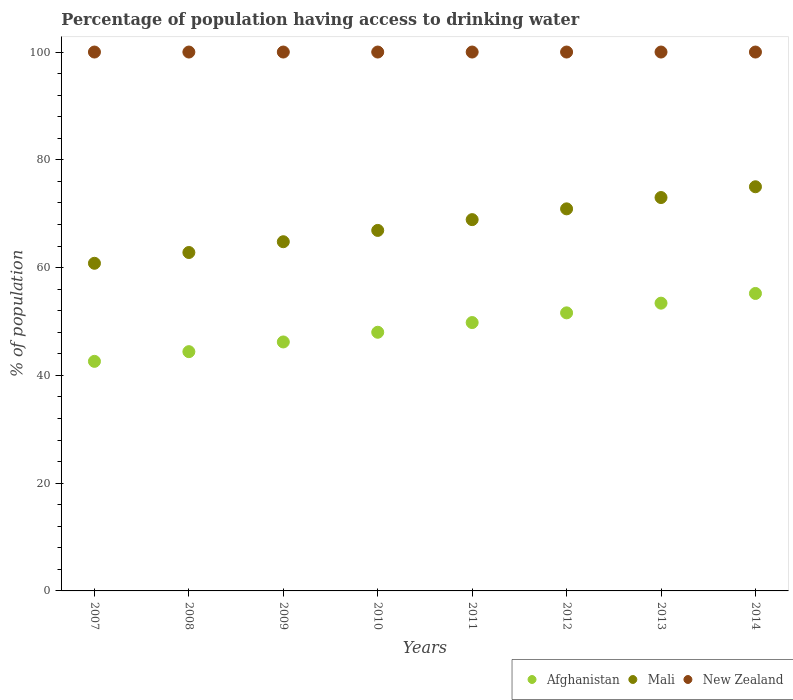What is the percentage of population having access to drinking water in New Zealand in 2009?
Make the answer very short. 100. Across all years, what is the maximum percentage of population having access to drinking water in Mali?
Make the answer very short. 75. Across all years, what is the minimum percentage of population having access to drinking water in New Zealand?
Ensure brevity in your answer.  100. In which year was the percentage of population having access to drinking water in Mali maximum?
Ensure brevity in your answer.  2014. What is the total percentage of population having access to drinking water in Afghanistan in the graph?
Provide a short and direct response. 391.2. What is the difference between the percentage of population having access to drinking water in Afghanistan in 2010 and that in 2013?
Your answer should be compact. -5.4. What is the difference between the percentage of population having access to drinking water in New Zealand in 2009 and the percentage of population having access to drinking water in Mali in 2008?
Give a very brief answer. 37.2. What is the average percentage of population having access to drinking water in New Zealand per year?
Ensure brevity in your answer.  100. In the year 2009, what is the difference between the percentage of population having access to drinking water in Mali and percentage of population having access to drinking water in New Zealand?
Your answer should be compact. -35.2. In how many years, is the percentage of population having access to drinking water in Mali greater than 76 %?
Your answer should be compact. 0. What is the ratio of the percentage of population having access to drinking water in Afghanistan in 2011 to that in 2012?
Offer a terse response. 0.97. What is the difference between the highest and the lowest percentage of population having access to drinking water in Afghanistan?
Make the answer very short. 12.6. Is the sum of the percentage of population having access to drinking water in New Zealand in 2009 and 2014 greater than the maximum percentage of population having access to drinking water in Mali across all years?
Your response must be concise. Yes. Is it the case that in every year, the sum of the percentage of population having access to drinking water in Mali and percentage of population having access to drinking water in New Zealand  is greater than the percentage of population having access to drinking water in Afghanistan?
Keep it short and to the point. Yes. Is the percentage of population having access to drinking water in Afghanistan strictly less than the percentage of population having access to drinking water in New Zealand over the years?
Ensure brevity in your answer.  Yes. How many dotlines are there?
Make the answer very short. 3. How many years are there in the graph?
Your answer should be very brief. 8. What is the difference between two consecutive major ticks on the Y-axis?
Provide a succinct answer. 20. Does the graph contain grids?
Keep it short and to the point. No. How are the legend labels stacked?
Keep it short and to the point. Horizontal. What is the title of the graph?
Your answer should be compact. Percentage of population having access to drinking water. What is the label or title of the X-axis?
Give a very brief answer. Years. What is the label or title of the Y-axis?
Provide a short and direct response. % of population. What is the % of population of Afghanistan in 2007?
Make the answer very short. 42.6. What is the % of population of Mali in 2007?
Keep it short and to the point. 60.8. What is the % of population in Afghanistan in 2008?
Provide a succinct answer. 44.4. What is the % of population in Mali in 2008?
Your answer should be compact. 62.8. What is the % of population in Afghanistan in 2009?
Offer a terse response. 46.2. What is the % of population of Mali in 2009?
Give a very brief answer. 64.8. What is the % of population in New Zealand in 2009?
Provide a short and direct response. 100. What is the % of population in Mali in 2010?
Your answer should be very brief. 66.9. What is the % of population of Afghanistan in 2011?
Give a very brief answer. 49.8. What is the % of population in Mali in 2011?
Ensure brevity in your answer.  68.9. What is the % of population of Afghanistan in 2012?
Offer a very short reply. 51.6. What is the % of population in Mali in 2012?
Your response must be concise. 70.9. What is the % of population in Afghanistan in 2013?
Make the answer very short. 53.4. What is the % of population in Mali in 2013?
Provide a succinct answer. 73. What is the % of population of Afghanistan in 2014?
Offer a terse response. 55.2. Across all years, what is the maximum % of population in Afghanistan?
Your response must be concise. 55.2. Across all years, what is the minimum % of population in Afghanistan?
Offer a very short reply. 42.6. Across all years, what is the minimum % of population in Mali?
Keep it short and to the point. 60.8. Across all years, what is the minimum % of population of New Zealand?
Ensure brevity in your answer.  100. What is the total % of population in Afghanistan in the graph?
Keep it short and to the point. 391.2. What is the total % of population in Mali in the graph?
Your response must be concise. 543.1. What is the total % of population of New Zealand in the graph?
Offer a very short reply. 800. What is the difference between the % of population in Afghanistan in 2007 and that in 2008?
Your answer should be compact. -1.8. What is the difference between the % of population of New Zealand in 2007 and that in 2008?
Your answer should be very brief. 0. What is the difference between the % of population in Afghanistan in 2007 and that in 2009?
Your response must be concise. -3.6. What is the difference between the % of population of Afghanistan in 2007 and that in 2010?
Provide a succinct answer. -5.4. What is the difference between the % of population in Mali in 2007 and that in 2011?
Your answer should be very brief. -8.1. What is the difference between the % of population in Afghanistan in 2007 and that in 2012?
Make the answer very short. -9. What is the difference between the % of population in Mali in 2007 and that in 2012?
Make the answer very short. -10.1. What is the difference between the % of population in New Zealand in 2007 and that in 2012?
Make the answer very short. 0. What is the difference between the % of population of Mali in 2007 and that in 2013?
Provide a succinct answer. -12.2. What is the difference between the % of population of Mali in 2007 and that in 2014?
Your answer should be very brief. -14.2. What is the difference between the % of population of Afghanistan in 2008 and that in 2009?
Your answer should be compact. -1.8. What is the difference between the % of population of Mali in 2008 and that in 2009?
Keep it short and to the point. -2. What is the difference between the % of population of Afghanistan in 2008 and that in 2011?
Make the answer very short. -5.4. What is the difference between the % of population in Mali in 2008 and that in 2011?
Offer a very short reply. -6.1. What is the difference between the % of population of Mali in 2008 and that in 2012?
Ensure brevity in your answer.  -8.1. What is the difference between the % of population of New Zealand in 2008 and that in 2012?
Provide a short and direct response. 0. What is the difference between the % of population in Mali in 2008 and that in 2014?
Make the answer very short. -12.2. What is the difference between the % of population in Mali in 2009 and that in 2010?
Give a very brief answer. -2.1. What is the difference between the % of population of Afghanistan in 2009 and that in 2011?
Provide a succinct answer. -3.6. What is the difference between the % of population in New Zealand in 2009 and that in 2012?
Make the answer very short. 0. What is the difference between the % of population in Afghanistan in 2009 and that in 2013?
Provide a succinct answer. -7.2. What is the difference between the % of population in Mali in 2009 and that in 2013?
Your response must be concise. -8.2. What is the difference between the % of population in Afghanistan in 2009 and that in 2014?
Ensure brevity in your answer.  -9. What is the difference between the % of population in New Zealand in 2009 and that in 2014?
Your answer should be compact. 0. What is the difference between the % of population in Afghanistan in 2010 and that in 2011?
Offer a terse response. -1.8. What is the difference between the % of population of Afghanistan in 2010 and that in 2012?
Keep it short and to the point. -3.6. What is the difference between the % of population in New Zealand in 2010 and that in 2012?
Offer a terse response. 0. What is the difference between the % of population of New Zealand in 2010 and that in 2013?
Your answer should be very brief. 0. What is the difference between the % of population of Mali in 2010 and that in 2014?
Provide a short and direct response. -8.1. What is the difference between the % of population of New Zealand in 2010 and that in 2014?
Make the answer very short. 0. What is the difference between the % of population in Afghanistan in 2011 and that in 2012?
Make the answer very short. -1.8. What is the difference between the % of population in New Zealand in 2011 and that in 2012?
Provide a short and direct response. 0. What is the difference between the % of population in Mali in 2011 and that in 2013?
Ensure brevity in your answer.  -4.1. What is the difference between the % of population in New Zealand in 2011 and that in 2013?
Provide a short and direct response. 0. What is the difference between the % of population of Afghanistan in 2011 and that in 2014?
Offer a very short reply. -5.4. What is the difference between the % of population in Mali in 2011 and that in 2014?
Make the answer very short. -6.1. What is the difference between the % of population of New Zealand in 2011 and that in 2014?
Provide a short and direct response. 0. What is the difference between the % of population of Afghanistan in 2013 and that in 2014?
Your response must be concise. -1.8. What is the difference between the % of population in Mali in 2013 and that in 2014?
Offer a terse response. -2. What is the difference between the % of population in New Zealand in 2013 and that in 2014?
Your answer should be compact. 0. What is the difference between the % of population in Afghanistan in 2007 and the % of population in Mali in 2008?
Offer a terse response. -20.2. What is the difference between the % of population in Afghanistan in 2007 and the % of population in New Zealand in 2008?
Your answer should be compact. -57.4. What is the difference between the % of population of Mali in 2007 and the % of population of New Zealand in 2008?
Your answer should be compact. -39.2. What is the difference between the % of population in Afghanistan in 2007 and the % of population in Mali in 2009?
Provide a succinct answer. -22.2. What is the difference between the % of population in Afghanistan in 2007 and the % of population in New Zealand in 2009?
Offer a terse response. -57.4. What is the difference between the % of population in Mali in 2007 and the % of population in New Zealand in 2009?
Your answer should be compact. -39.2. What is the difference between the % of population of Afghanistan in 2007 and the % of population of Mali in 2010?
Offer a terse response. -24.3. What is the difference between the % of population in Afghanistan in 2007 and the % of population in New Zealand in 2010?
Your answer should be compact. -57.4. What is the difference between the % of population of Mali in 2007 and the % of population of New Zealand in 2010?
Provide a succinct answer. -39.2. What is the difference between the % of population of Afghanistan in 2007 and the % of population of Mali in 2011?
Offer a terse response. -26.3. What is the difference between the % of population in Afghanistan in 2007 and the % of population in New Zealand in 2011?
Give a very brief answer. -57.4. What is the difference between the % of population in Mali in 2007 and the % of population in New Zealand in 2011?
Offer a very short reply. -39.2. What is the difference between the % of population of Afghanistan in 2007 and the % of population of Mali in 2012?
Your answer should be compact. -28.3. What is the difference between the % of population of Afghanistan in 2007 and the % of population of New Zealand in 2012?
Provide a short and direct response. -57.4. What is the difference between the % of population of Mali in 2007 and the % of population of New Zealand in 2012?
Give a very brief answer. -39.2. What is the difference between the % of population of Afghanistan in 2007 and the % of population of Mali in 2013?
Ensure brevity in your answer.  -30.4. What is the difference between the % of population in Afghanistan in 2007 and the % of population in New Zealand in 2013?
Keep it short and to the point. -57.4. What is the difference between the % of population in Mali in 2007 and the % of population in New Zealand in 2013?
Keep it short and to the point. -39.2. What is the difference between the % of population of Afghanistan in 2007 and the % of population of Mali in 2014?
Keep it short and to the point. -32.4. What is the difference between the % of population in Afghanistan in 2007 and the % of population in New Zealand in 2014?
Ensure brevity in your answer.  -57.4. What is the difference between the % of population of Mali in 2007 and the % of population of New Zealand in 2014?
Your answer should be compact. -39.2. What is the difference between the % of population of Afghanistan in 2008 and the % of population of Mali in 2009?
Provide a short and direct response. -20.4. What is the difference between the % of population of Afghanistan in 2008 and the % of population of New Zealand in 2009?
Offer a terse response. -55.6. What is the difference between the % of population of Mali in 2008 and the % of population of New Zealand in 2009?
Your answer should be compact. -37.2. What is the difference between the % of population of Afghanistan in 2008 and the % of population of Mali in 2010?
Your answer should be compact. -22.5. What is the difference between the % of population in Afghanistan in 2008 and the % of population in New Zealand in 2010?
Make the answer very short. -55.6. What is the difference between the % of population in Mali in 2008 and the % of population in New Zealand in 2010?
Provide a succinct answer. -37.2. What is the difference between the % of population in Afghanistan in 2008 and the % of population in Mali in 2011?
Your response must be concise. -24.5. What is the difference between the % of population of Afghanistan in 2008 and the % of population of New Zealand in 2011?
Keep it short and to the point. -55.6. What is the difference between the % of population of Mali in 2008 and the % of population of New Zealand in 2011?
Give a very brief answer. -37.2. What is the difference between the % of population of Afghanistan in 2008 and the % of population of Mali in 2012?
Make the answer very short. -26.5. What is the difference between the % of population of Afghanistan in 2008 and the % of population of New Zealand in 2012?
Give a very brief answer. -55.6. What is the difference between the % of population in Mali in 2008 and the % of population in New Zealand in 2012?
Your answer should be very brief. -37.2. What is the difference between the % of population in Afghanistan in 2008 and the % of population in Mali in 2013?
Your response must be concise. -28.6. What is the difference between the % of population in Afghanistan in 2008 and the % of population in New Zealand in 2013?
Ensure brevity in your answer.  -55.6. What is the difference between the % of population in Mali in 2008 and the % of population in New Zealand in 2013?
Your response must be concise. -37.2. What is the difference between the % of population of Afghanistan in 2008 and the % of population of Mali in 2014?
Offer a terse response. -30.6. What is the difference between the % of population of Afghanistan in 2008 and the % of population of New Zealand in 2014?
Ensure brevity in your answer.  -55.6. What is the difference between the % of population of Mali in 2008 and the % of population of New Zealand in 2014?
Keep it short and to the point. -37.2. What is the difference between the % of population of Afghanistan in 2009 and the % of population of Mali in 2010?
Offer a very short reply. -20.7. What is the difference between the % of population in Afghanistan in 2009 and the % of population in New Zealand in 2010?
Keep it short and to the point. -53.8. What is the difference between the % of population of Mali in 2009 and the % of population of New Zealand in 2010?
Offer a very short reply. -35.2. What is the difference between the % of population of Afghanistan in 2009 and the % of population of Mali in 2011?
Offer a terse response. -22.7. What is the difference between the % of population of Afghanistan in 2009 and the % of population of New Zealand in 2011?
Ensure brevity in your answer.  -53.8. What is the difference between the % of population in Mali in 2009 and the % of population in New Zealand in 2011?
Your answer should be compact. -35.2. What is the difference between the % of population of Afghanistan in 2009 and the % of population of Mali in 2012?
Offer a very short reply. -24.7. What is the difference between the % of population of Afghanistan in 2009 and the % of population of New Zealand in 2012?
Your response must be concise. -53.8. What is the difference between the % of population of Mali in 2009 and the % of population of New Zealand in 2012?
Give a very brief answer. -35.2. What is the difference between the % of population in Afghanistan in 2009 and the % of population in Mali in 2013?
Your answer should be very brief. -26.8. What is the difference between the % of population of Afghanistan in 2009 and the % of population of New Zealand in 2013?
Your answer should be compact. -53.8. What is the difference between the % of population in Mali in 2009 and the % of population in New Zealand in 2013?
Your answer should be very brief. -35.2. What is the difference between the % of population in Afghanistan in 2009 and the % of population in Mali in 2014?
Ensure brevity in your answer.  -28.8. What is the difference between the % of population of Afghanistan in 2009 and the % of population of New Zealand in 2014?
Your answer should be compact. -53.8. What is the difference between the % of population in Mali in 2009 and the % of population in New Zealand in 2014?
Offer a terse response. -35.2. What is the difference between the % of population of Afghanistan in 2010 and the % of population of Mali in 2011?
Keep it short and to the point. -20.9. What is the difference between the % of population of Afghanistan in 2010 and the % of population of New Zealand in 2011?
Ensure brevity in your answer.  -52. What is the difference between the % of population of Mali in 2010 and the % of population of New Zealand in 2011?
Offer a very short reply. -33.1. What is the difference between the % of population of Afghanistan in 2010 and the % of population of Mali in 2012?
Offer a terse response. -22.9. What is the difference between the % of population of Afghanistan in 2010 and the % of population of New Zealand in 2012?
Offer a terse response. -52. What is the difference between the % of population in Mali in 2010 and the % of population in New Zealand in 2012?
Offer a terse response. -33.1. What is the difference between the % of population of Afghanistan in 2010 and the % of population of Mali in 2013?
Make the answer very short. -25. What is the difference between the % of population of Afghanistan in 2010 and the % of population of New Zealand in 2013?
Offer a very short reply. -52. What is the difference between the % of population in Mali in 2010 and the % of population in New Zealand in 2013?
Make the answer very short. -33.1. What is the difference between the % of population in Afghanistan in 2010 and the % of population in Mali in 2014?
Give a very brief answer. -27. What is the difference between the % of population of Afghanistan in 2010 and the % of population of New Zealand in 2014?
Provide a short and direct response. -52. What is the difference between the % of population of Mali in 2010 and the % of population of New Zealand in 2014?
Offer a terse response. -33.1. What is the difference between the % of population of Afghanistan in 2011 and the % of population of Mali in 2012?
Provide a short and direct response. -21.1. What is the difference between the % of population of Afghanistan in 2011 and the % of population of New Zealand in 2012?
Keep it short and to the point. -50.2. What is the difference between the % of population of Mali in 2011 and the % of population of New Zealand in 2012?
Keep it short and to the point. -31.1. What is the difference between the % of population in Afghanistan in 2011 and the % of population in Mali in 2013?
Offer a terse response. -23.2. What is the difference between the % of population in Afghanistan in 2011 and the % of population in New Zealand in 2013?
Offer a very short reply. -50.2. What is the difference between the % of population in Mali in 2011 and the % of population in New Zealand in 2013?
Keep it short and to the point. -31.1. What is the difference between the % of population of Afghanistan in 2011 and the % of population of Mali in 2014?
Keep it short and to the point. -25.2. What is the difference between the % of population in Afghanistan in 2011 and the % of population in New Zealand in 2014?
Offer a terse response. -50.2. What is the difference between the % of population of Mali in 2011 and the % of population of New Zealand in 2014?
Provide a succinct answer. -31.1. What is the difference between the % of population in Afghanistan in 2012 and the % of population in Mali in 2013?
Keep it short and to the point. -21.4. What is the difference between the % of population of Afghanistan in 2012 and the % of population of New Zealand in 2013?
Offer a very short reply. -48.4. What is the difference between the % of population of Mali in 2012 and the % of population of New Zealand in 2013?
Your response must be concise. -29.1. What is the difference between the % of population of Afghanistan in 2012 and the % of population of Mali in 2014?
Offer a very short reply. -23.4. What is the difference between the % of population in Afghanistan in 2012 and the % of population in New Zealand in 2014?
Your answer should be very brief. -48.4. What is the difference between the % of population in Mali in 2012 and the % of population in New Zealand in 2014?
Your answer should be very brief. -29.1. What is the difference between the % of population in Afghanistan in 2013 and the % of population in Mali in 2014?
Make the answer very short. -21.6. What is the difference between the % of population of Afghanistan in 2013 and the % of population of New Zealand in 2014?
Offer a very short reply. -46.6. What is the difference between the % of population of Mali in 2013 and the % of population of New Zealand in 2014?
Your answer should be very brief. -27. What is the average % of population of Afghanistan per year?
Keep it short and to the point. 48.9. What is the average % of population of Mali per year?
Offer a very short reply. 67.89. What is the average % of population in New Zealand per year?
Keep it short and to the point. 100. In the year 2007, what is the difference between the % of population of Afghanistan and % of population of Mali?
Provide a succinct answer. -18.2. In the year 2007, what is the difference between the % of population in Afghanistan and % of population in New Zealand?
Provide a short and direct response. -57.4. In the year 2007, what is the difference between the % of population in Mali and % of population in New Zealand?
Your answer should be compact. -39.2. In the year 2008, what is the difference between the % of population of Afghanistan and % of population of Mali?
Provide a short and direct response. -18.4. In the year 2008, what is the difference between the % of population in Afghanistan and % of population in New Zealand?
Give a very brief answer. -55.6. In the year 2008, what is the difference between the % of population of Mali and % of population of New Zealand?
Make the answer very short. -37.2. In the year 2009, what is the difference between the % of population in Afghanistan and % of population in Mali?
Give a very brief answer. -18.6. In the year 2009, what is the difference between the % of population of Afghanistan and % of population of New Zealand?
Your response must be concise. -53.8. In the year 2009, what is the difference between the % of population of Mali and % of population of New Zealand?
Offer a very short reply. -35.2. In the year 2010, what is the difference between the % of population of Afghanistan and % of population of Mali?
Your response must be concise. -18.9. In the year 2010, what is the difference between the % of population of Afghanistan and % of population of New Zealand?
Your answer should be compact. -52. In the year 2010, what is the difference between the % of population in Mali and % of population in New Zealand?
Keep it short and to the point. -33.1. In the year 2011, what is the difference between the % of population of Afghanistan and % of population of Mali?
Provide a short and direct response. -19.1. In the year 2011, what is the difference between the % of population of Afghanistan and % of population of New Zealand?
Give a very brief answer. -50.2. In the year 2011, what is the difference between the % of population in Mali and % of population in New Zealand?
Your response must be concise. -31.1. In the year 2012, what is the difference between the % of population of Afghanistan and % of population of Mali?
Provide a succinct answer. -19.3. In the year 2012, what is the difference between the % of population in Afghanistan and % of population in New Zealand?
Ensure brevity in your answer.  -48.4. In the year 2012, what is the difference between the % of population of Mali and % of population of New Zealand?
Give a very brief answer. -29.1. In the year 2013, what is the difference between the % of population of Afghanistan and % of population of Mali?
Offer a very short reply. -19.6. In the year 2013, what is the difference between the % of population of Afghanistan and % of population of New Zealand?
Offer a very short reply. -46.6. In the year 2014, what is the difference between the % of population in Afghanistan and % of population in Mali?
Give a very brief answer. -19.8. In the year 2014, what is the difference between the % of population of Afghanistan and % of population of New Zealand?
Offer a very short reply. -44.8. In the year 2014, what is the difference between the % of population of Mali and % of population of New Zealand?
Offer a terse response. -25. What is the ratio of the % of population in Afghanistan in 2007 to that in 2008?
Your answer should be compact. 0.96. What is the ratio of the % of population in Mali in 2007 to that in 2008?
Provide a short and direct response. 0.97. What is the ratio of the % of population of Afghanistan in 2007 to that in 2009?
Offer a terse response. 0.92. What is the ratio of the % of population in Mali in 2007 to that in 2009?
Provide a succinct answer. 0.94. What is the ratio of the % of population in New Zealand in 2007 to that in 2009?
Your answer should be very brief. 1. What is the ratio of the % of population of Afghanistan in 2007 to that in 2010?
Provide a succinct answer. 0.89. What is the ratio of the % of population in Mali in 2007 to that in 2010?
Your answer should be very brief. 0.91. What is the ratio of the % of population of Afghanistan in 2007 to that in 2011?
Your response must be concise. 0.86. What is the ratio of the % of population in Mali in 2007 to that in 2011?
Provide a short and direct response. 0.88. What is the ratio of the % of population of New Zealand in 2007 to that in 2011?
Keep it short and to the point. 1. What is the ratio of the % of population of Afghanistan in 2007 to that in 2012?
Your answer should be compact. 0.83. What is the ratio of the % of population of Mali in 2007 to that in 2012?
Provide a short and direct response. 0.86. What is the ratio of the % of population in New Zealand in 2007 to that in 2012?
Give a very brief answer. 1. What is the ratio of the % of population of Afghanistan in 2007 to that in 2013?
Your answer should be very brief. 0.8. What is the ratio of the % of population of Mali in 2007 to that in 2013?
Give a very brief answer. 0.83. What is the ratio of the % of population in New Zealand in 2007 to that in 2013?
Give a very brief answer. 1. What is the ratio of the % of population in Afghanistan in 2007 to that in 2014?
Provide a succinct answer. 0.77. What is the ratio of the % of population in Mali in 2007 to that in 2014?
Provide a short and direct response. 0.81. What is the ratio of the % of population in New Zealand in 2007 to that in 2014?
Your answer should be very brief. 1. What is the ratio of the % of population of Afghanistan in 2008 to that in 2009?
Provide a succinct answer. 0.96. What is the ratio of the % of population in Mali in 2008 to that in 2009?
Give a very brief answer. 0.97. What is the ratio of the % of population in New Zealand in 2008 to that in 2009?
Make the answer very short. 1. What is the ratio of the % of population in Afghanistan in 2008 to that in 2010?
Provide a succinct answer. 0.93. What is the ratio of the % of population in Mali in 2008 to that in 2010?
Your response must be concise. 0.94. What is the ratio of the % of population in Afghanistan in 2008 to that in 2011?
Your answer should be very brief. 0.89. What is the ratio of the % of population in Mali in 2008 to that in 2011?
Your response must be concise. 0.91. What is the ratio of the % of population of New Zealand in 2008 to that in 2011?
Provide a short and direct response. 1. What is the ratio of the % of population of Afghanistan in 2008 to that in 2012?
Provide a succinct answer. 0.86. What is the ratio of the % of population of Mali in 2008 to that in 2012?
Offer a terse response. 0.89. What is the ratio of the % of population of Afghanistan in 2008 to that in 2013?
Provide a short and direct response. 0.83. What is the ratio of the % of population of Mali in 2008 to that in 2013?
Keep it short and to the point. 0.86. What is the ratio of the % of population in Afghanistan in 2008 to that in 2014?
Your response must be concise. 0.8. What is the ratio of the % of population of Mali in 2008 to that in 2014?
Your answer should be very brief. 0.84. What is the ratio of the % of population in New Zealand in 2008 to that in 2014?
Ensure brevity in your answer.  1. What is the ratio of the % of population in Afghanistan in 2009 to that in 2010?
Offer a very short reply. 0.96. What is the ratio of the % of population of Mali in 2009 to that in 2010?
Keep it short and to the point. 0.97. What is the ratio of the % of population of Afghanistan in 2009 to that in 2011?
Your answer should be very brief. 0.93. What is the ratio of the % of population in Mali in 2009 to that in 2011?
Your answer should be compact. 0.94. What is the ratio of the % of population in Afghanistan in 2009 to that in 2012?
Your response must be concise. 0.9. What is the ratio of the % of population of Mali in 2009 to that in 2012?
Your answer should be very brief. 0.91. What is the ratio of the % of population in New Zealand in 2009 to that in 2012?
Offer a terse response. 1. What is the ratio of the % of population in Afghanistan in 2009 to that in 2013?
Keep it short and to the point. 0.87. What is the ratio of the % of population of Mali in 2009 to that in 2013?
Your answer should be compact. 0.89. What is the ratio of the % of population of Afghanistan in 2009 to that in 2014?
Provide a short and direct response. 0.84. What is the ratio of the % of population of Mali in 2009 to that in 2014?
Make the answer very short. 0.86. What is the ratio of the % of population in Afghanistan in 2010 to that in 2011?
Ensure brevity in your answer.  0.96. What is the ratio of the % of population in Afghanistan in 2010 to that in 2012?
Provide a succinct answer. 0.93. What is the ratio of the % of population of Mali in 2010 to that in 2012?
Offer a terse response. 0.94. What is the ratio of the % of population in New Zealand in 2010 to that in 2012?
Your answer should be compact. 1. What is the ratio of the % of population of Afghanistan in 2010 to that in 2013?
Offer a very short reply. 0.9. What is the ratio of the % of population of Mali in 2010 to that in 2013?
Your answer should be very brief. 0.92. What is the ratio of the % of population of Afghanistan in 2010 to that in 2014?
Keep it short and to the point. 0.87. What is the ratio of the % of population of Mali in 2010 to that in 2014?
Provide a succinct answer. 0.89. What is the ratio of the % of population of New Zealand in 2010 to that in 2014?
Give a very brief answer. 1. What is the ratio of the % of population of Afghanistan in 2011 to that in 2012?
Your response must be concise. 0.97. What is the ratio of the % of population of Mali in 2011 to that in 2012?
Ensure brevity in your answer.  0.97. What is the ratio of the % of population of New Zealand in 2011 to that in 2012?
Keep it short and to the point. 1. What is the ratio of the % of population of Afghanistan in 2011 to that in 2013?
Offer a terse response. 0.93. What is the ratio of the % of population in Mali in 2011 to that in 2013?
Offer a terse response. 0.94. What is the ratio of the % of population in New Zealand in 2011 to that in 2013?
Make the answer very short. 1. What is the ratio of the % of population of Afghanistan in 2011 to that in 2014?
Make the answer very short. 0.9. What is the ratio of the % of population of Mali in 2011 to that in 2014?
Your response must be concise. 0.92. What is the ratio of the % of population in Afghanistan in 2012 to that in 2013?
Your answer should be very brief. 0.97. What is the ratio of the % of population of Mali in 2012 to that in 2013?
Make the answer very short. 0.97. What is the ratio of the % of population in New Zealand in 2012 to that in 2013?
Your response must be concise. 1. What is the ratio of the % of population of Afghanistan in 2012 to that in 2014?
Provide a short and direct response. 0.93. What is the ratio of the % of population in Mali in 2012 to that in 2014?
Your answer should be very brief. 0.95. What is the ratio of the % of population in New Zealand in 2012 to that in 2014?
Your answer should be very brief. 1. What is the ratio of the % of population of Afghanistan in 2013 to that in 2014?
Your response must be concise. 0.97. What is the ratio of the % of population of Mali in 2013 to that in 2014?
Provide a short and direct response. 0.97. What is the ratio of the % of population of New Zealand in 2013 to that in 2014?
Your answer should be compact. 1. What is the difference between the highest and the second highest % of population in New Zealand?
Offer a very short reply. 0. What is the difference between the highest and the lowest % of population in Afghanistan?
Make the answer very short. 12.6. What is the difference between the highest and the lowest % of population of Mali?
Offer a terse response. 14.2. What is the difference between the highest and the lowest % of population in New Zealand?
Provide a short and direct response. 0. 